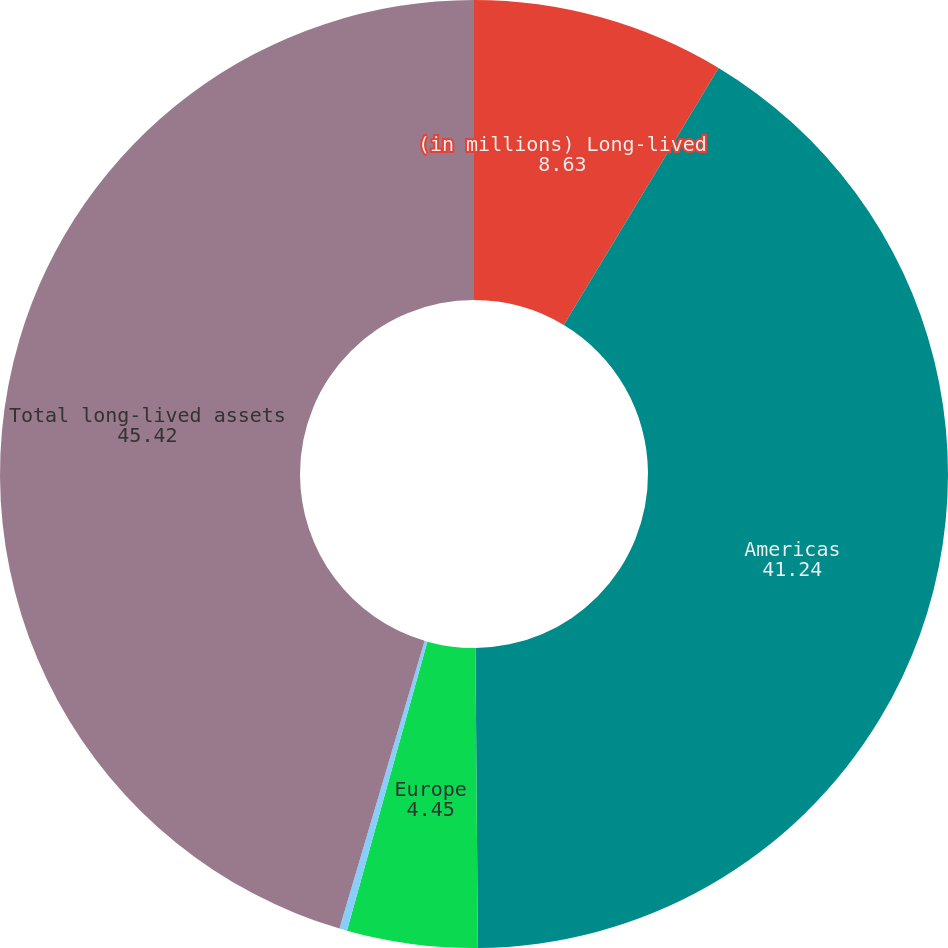Convert chart to OTSL. <chart><loc_0><loc_0><loc_500><loc_500><pie_chart><fcel>(in millions) Long-lived<fcel>Americas<fcel>Europe<fcel>Asia-Pacific<fcel>Total long-lived assets<nl><fcel>8.63%<fcel>41.24%<fcel>4.45%<fcel>0.26%<fcel>45.42%<nl></chart> 